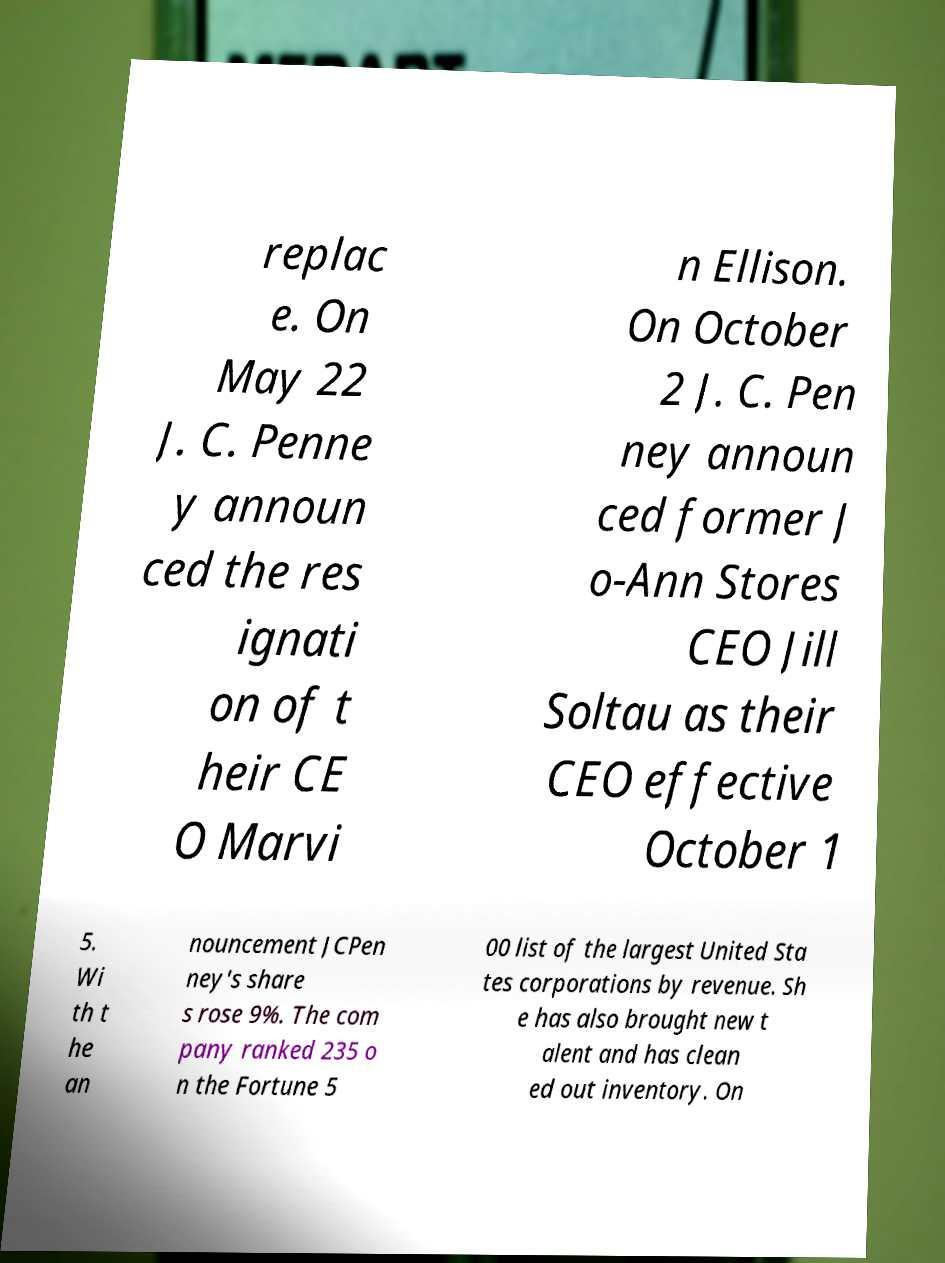What messages or text are displayed in this image? I need them in a readable, typed format. replac e. On May 22 J. C. Penne y announ ced the res ignati on of t heir CE O Marvi n Ellison. On October 2 J. C. Pen ney announ ced former J o-Ann Stores CEO Jill Soltau as their CEO effective October 1 5. Wi th t he an nouncement JCPen ney's share s rose 9%. The com pany ranked 235 o n the Fortune 5 00 list of the largest United Sta tes corporations by revenue. Sh e has also brought new t alent and has clean ed out inventory. On 